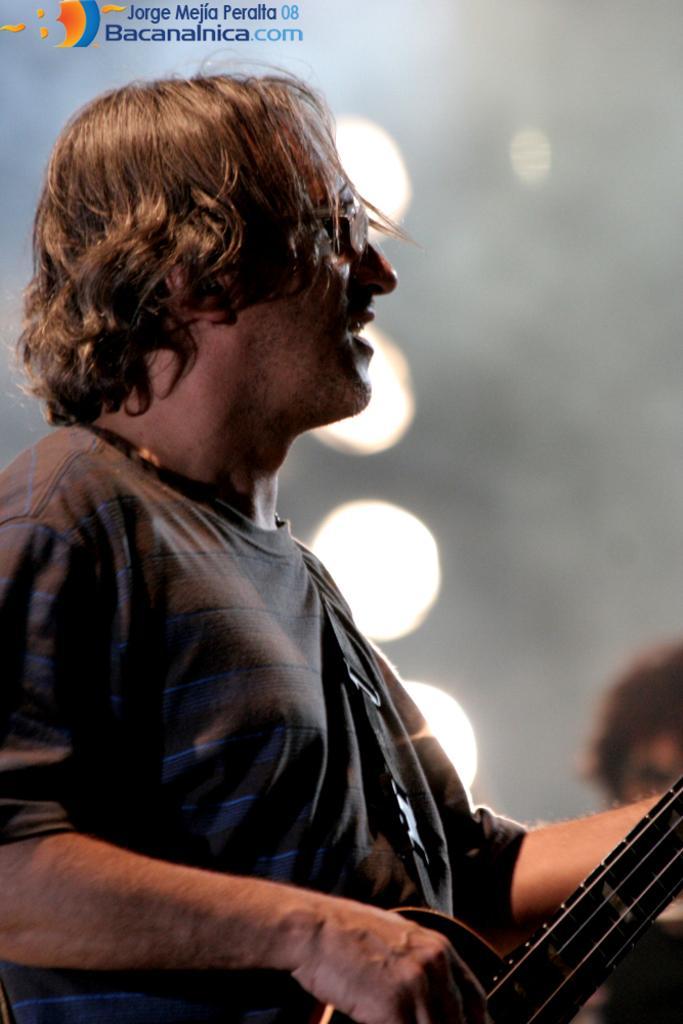Could you give a brief overview of what you see in this image? This is the picture of the man standing and playing the guitar in his hand. 